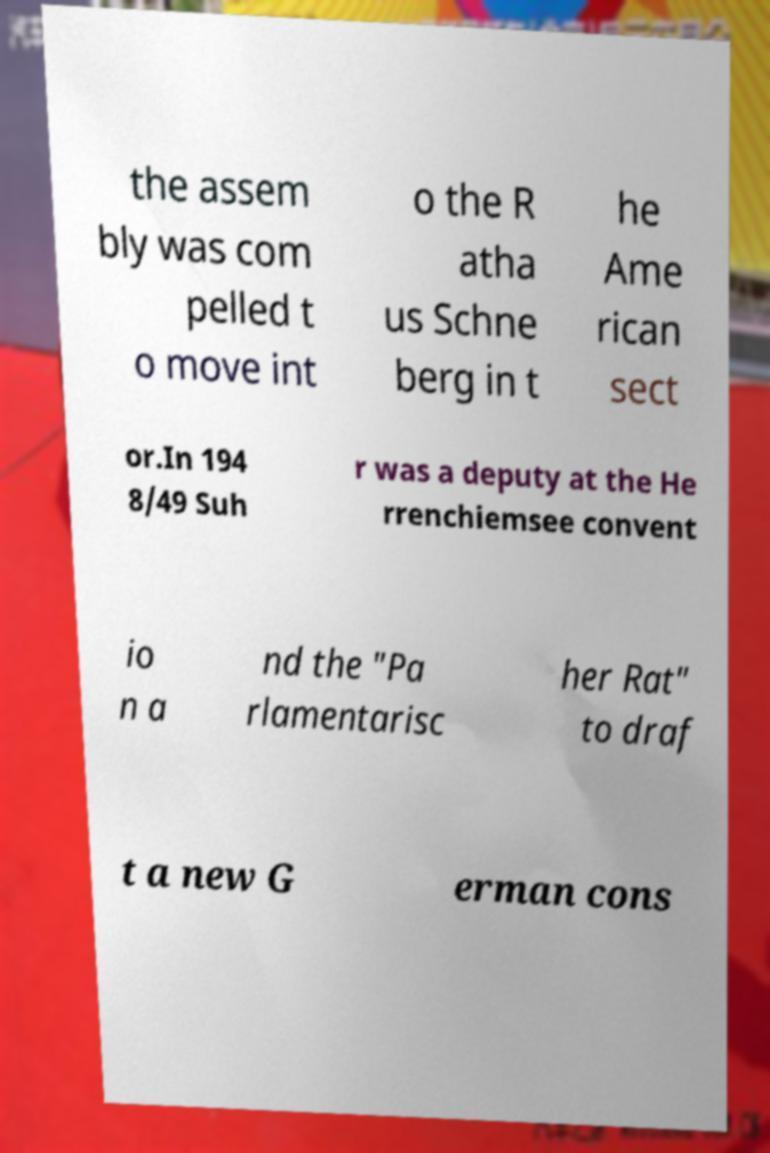For documentation purposes, I need the text within this image transcribed. Could you provide that? the assem bly was com pelled t o move int o the R atha us Schne berg in t he Ame rican sect or.In 194 8/49 Suh r was a deputy at the He rrenchiemsee convent io n a nd the "Pa rlamentarisc her Rat" to draf t a new G erman cons 